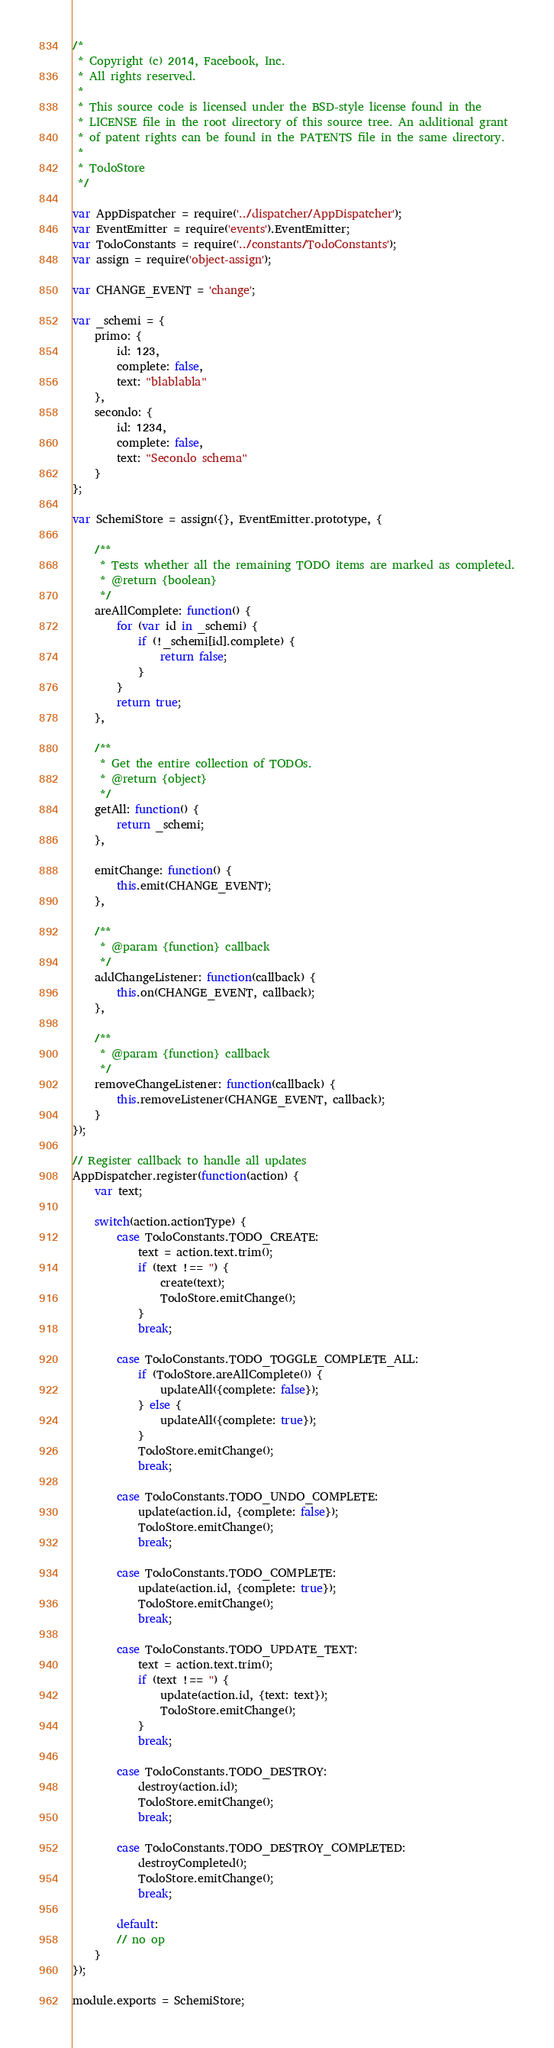<code> <loc_0><loc_0><loc_500><loc_500><_JavaScript_>/*
 * Copyright (c) 2014, Facebook, Inc.
 * All rights reserved.
 *
 * This source code is licensed under the BSD-style license found in the
 * LICENSE file in the root directory of this source tree. An additional grant
 * of patent rights can be found in the PATENTS file in the same directory.
 *
 * TodoStore
 */

var AppDispatcher = require('../dispatcher/AppDispatcher');
var EventEmitter = require('events').EventEmitter;
var TodoConstants = require('../constants/TodoConstants');
var assign = require('object-assign');

var CHANGE_EVENT = 'change';

var _schemi = {
    primo: {
        id: 123,
        complete: false,
        text: "blablabla"
    },
    secondo: {
        id: 1234,
        complete: false,
        text: "Secondo schema"
    }
};

var SchemiStore = assign({}, EventEmitter.prototype, {

    /**
     * Tests whether all the remaining TODO items are marked as completed.
     * @return {boolean}
     */
    areAllComplete: function() {
        for (var id in _schemi) {
            if (!_schemi[id].complete) {
                return false;
            }
        }
        return true;
    },

    /**
     * Get the entire collection of TODOs.
     * @return {object}
     */
    getAll: function() {
        return _schemi;
    },

    emitChange: function() {
        this.emit(CHANGE_EVENT);
    },

    /**
     * @param {function} callback
     */
    addChangeListener: function(callback) {
        this.on(CHANGE_EVENT, callback);
    },

    /**
     * @param {function} callback
     */
    removeChangeListener: function(callback) {
        this.removeListener(CHANGE_EVENT, callback);
    }
});

// Register callback to handle all updates
AppDispatcher.register(function(action) {
    var text;

    switch(action.actionType) {
        case TodoConstants.TODO_CREATE:
            text = action.text.trim();
            if (text !== '') {
                create(text);
                TodoStore.emitChange();
            }
            break;

        case TodoConstants.TODO_TOGGLE_COMPLETE_ALL:
            if (TodoStore.areAllComplete()) {
                updateAll({complete: false});
            } else {
                updateAll({complete: true});
            }
            TodoStore.emitChange();
            break;

        case TodoConstants.TODO_UNDO_COMPLETE:
            update(action.id, {complete: false});
            TodoStore.emitChange();
            break;

        case TodoConstants.TODO_COMPLETE:
            update(action.id, {complete: true});
            TodoStore.emitChange();
            break;

        case TodoConstants.TODO_UPDATE_TEXT:
            text = action.text.trim();
            if (text !== '') {
                update(action.id, {text: text});
                TodoStore.emitChange();
            }
            break;

        case TodoConstants.TODO_DESTROY:
            destroy(action.id);
            TodoStore.emitChange();
            break;

        case TodoConstants.TODO_DESTROY_COMPLETED:
            destroyCompleted();
            TodoStore.emitChange();
            break;

        default:
        // no op
    }
});

module.exports = SchemiStore;
</code> 